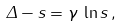<formula> <loc_0><loc_0><loc_500><loc_500>\Delta - s = \gamma \, \ln s \, ,</formula> 